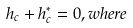<formula> <loc_0><loc_0><loc_500><loc_500>h _ { c } + h ^ { * } _ { c } = 0 , w h e r e</formula> 